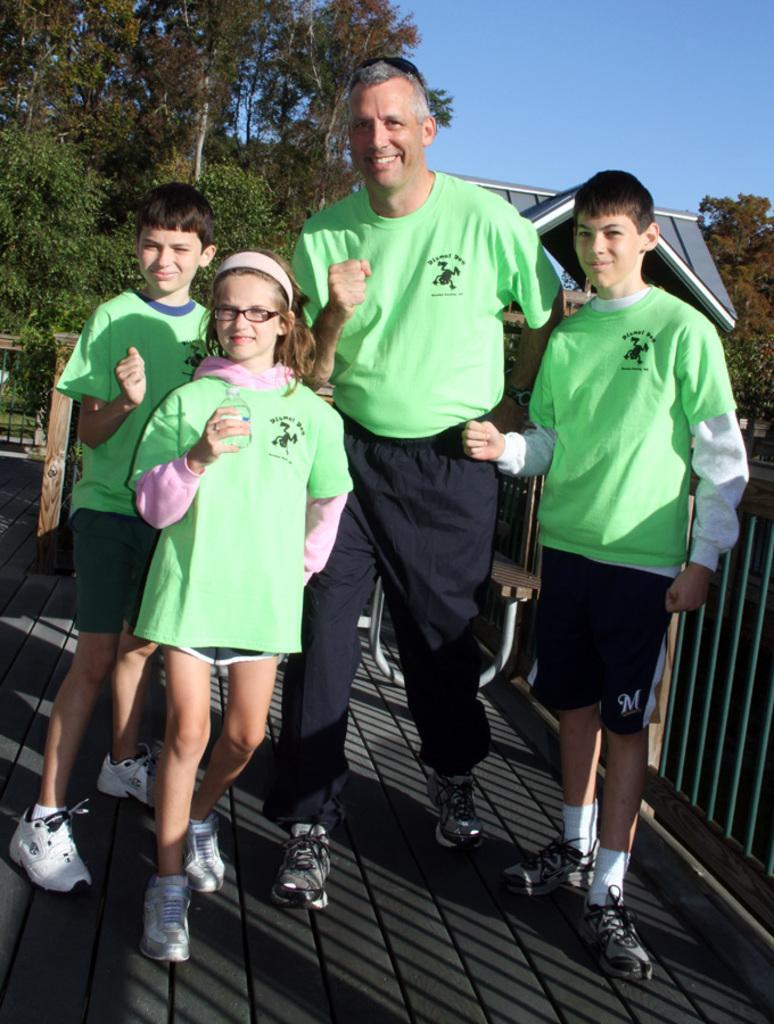How would you summarize this image in a sentence or two? In the image in the center, we can see four people are standing and they are smiling, which we can see on their faces. In the background, we can see the sky, trees, one building, roof and fence. 